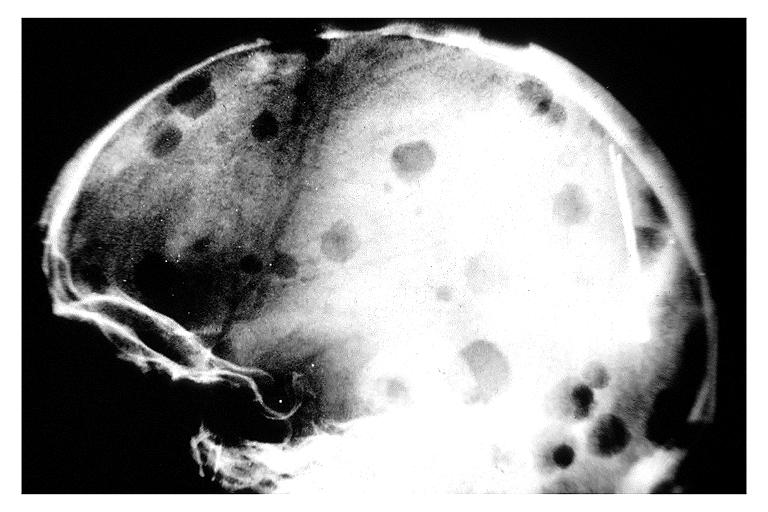s acid present?
Answer the question using a single word or phrase. No 